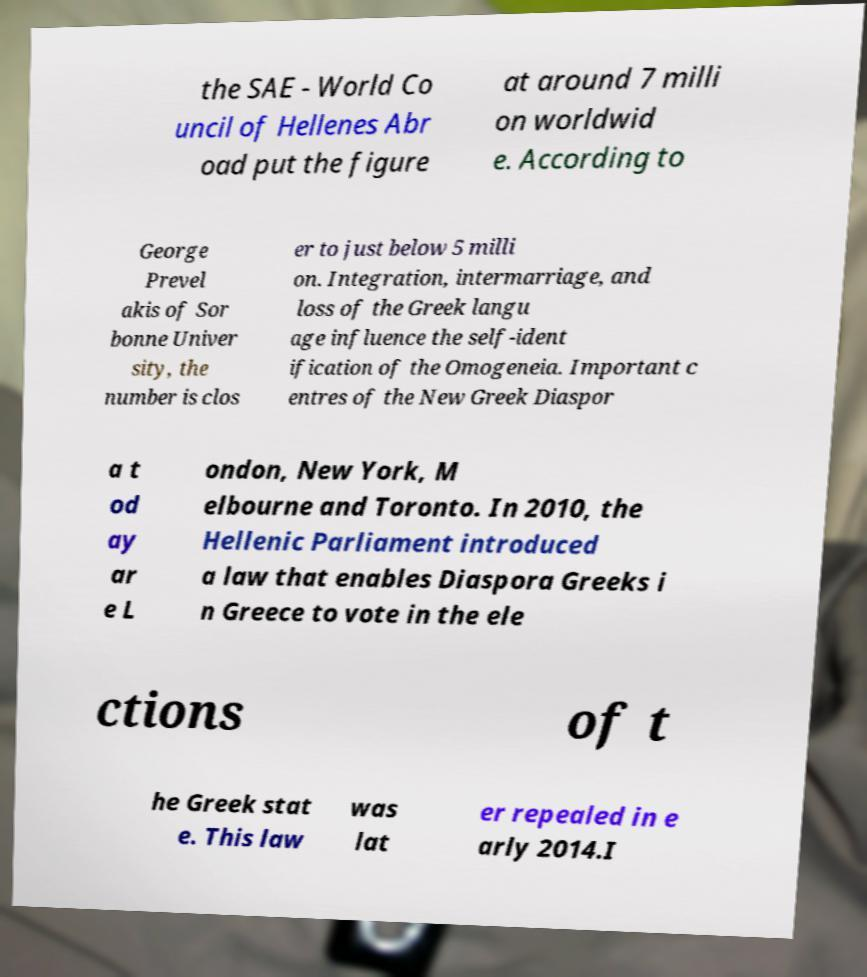I need the written content from this picture converted into text. Can you do that? the SAE - World Co uncil of Hellenes Abr oad put the figure at around 7 milli on worldwid e. According to George Prevel akis of Sor bonne Univer sity, the number is clos er to just below 5 milli on. Integration, intermarriage, and loss of the Greek langu age influence the self-ident ification of the Omogeneia. Important c entres of the New Greek Diaspor a t od ay ar e L ondon, New York, M elbourne and Toronto. In 2010, the Hellenic Parliament introduced a law that enables Diaspora Greeks i n Greece to vote in the ele ctions of t he Greek stat e. This law was lat er repealed in e arly 2014.I 